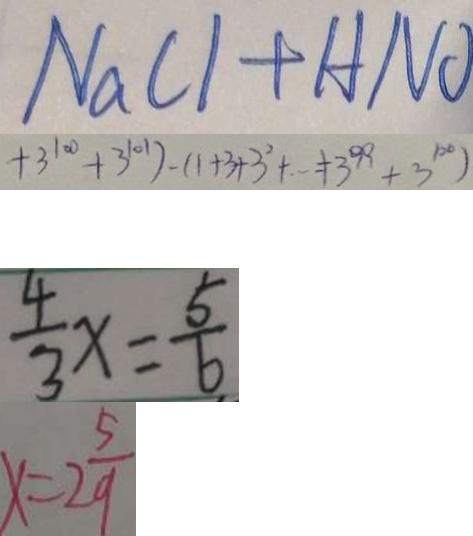Convert formula to latex. <formula><loc_0><loc_0><loc_500><loc_500>N a C 1 + H N O 
 + 3 ^ { 1 0 0 } + 3 ^ { 1 0 1 } ) - ( 1 + 3 + 3 ^ { 2 } + \cdots + 3 ^ { 9 9 } + 3 ^ { 1 0 0 } ) 
 \frac { 4 } { 3 } x = \frac { 5 } { 6 } 
 x = 2 \frac { 5 } { 9 }</formula> 